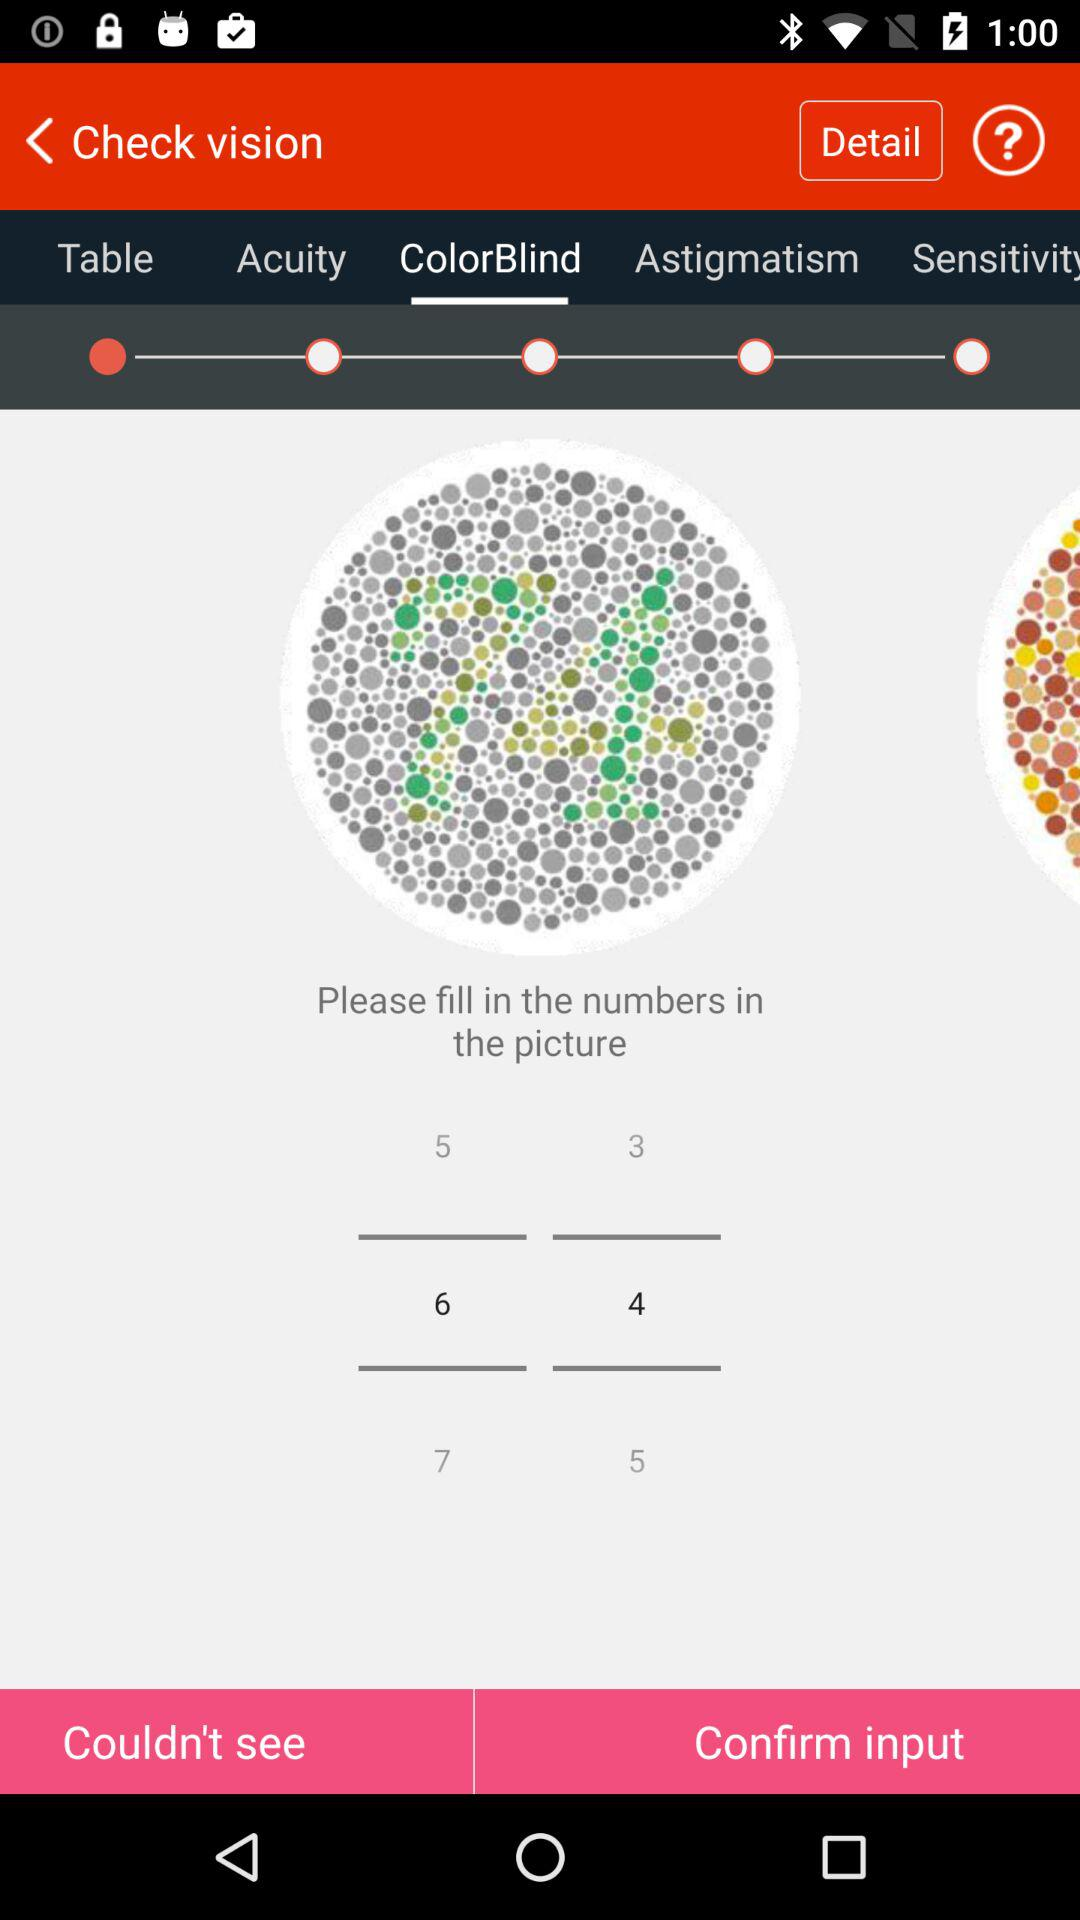Which tab has been selected? The tab "ColorBlind" has been selected. 